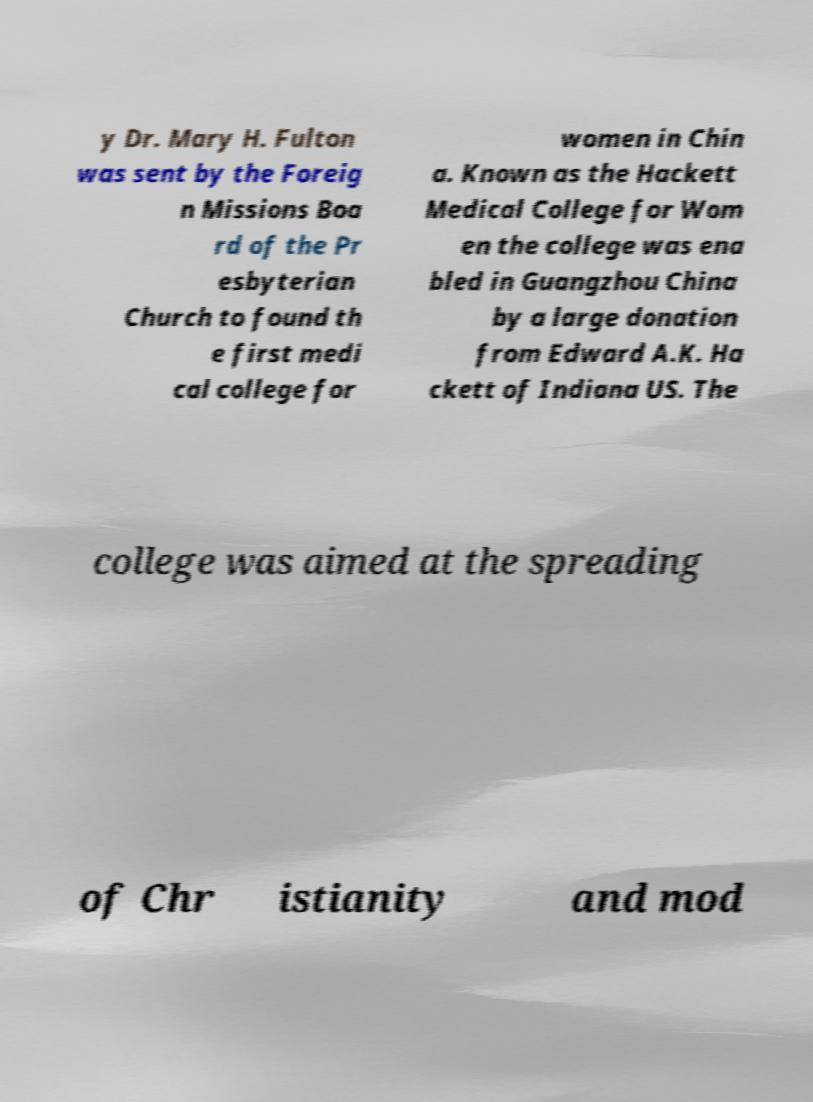There's text embedded in this image that I need extracted. Can you transcribe it verbatim? y Dr. Mary H. Fulton was sent by the Foreig n Missions Boa rd of the Pr esbyterian Church to found th e first medi cal college for women in Chin a. Known as the Hackett Medical College for Wom en the college was ena bled in Guangzhou China by a large donation from Edward A.K. Ha ckett of Indiana US. The college was aimed at the spreading of Chr istianity and mod 